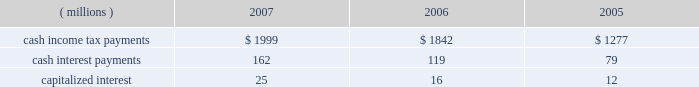In september 2006 , the fasb issued sfas no .
158 , 201cemployers 2019 accounting for defined benefit pension and other postretirement plans , an amendment of fasb statements no .
87 , 88 , 106 and 132 ( r ) . 201d this standard eliminated the requirement for a 201cminimum pension liability adjustment 201d that was previously required under sfas no .
87 and required employers to recognize the underfunded or overfunded status of a defined benefit plan as an asset or liability in its statement of financial position .
In 2006 , as a result of the implementation of sfas no .
158 , the company recognized an after-tax decrease in accumulated other comprehensive income of $ 1.187 billion and $ 513 million for the u.s .
And international pension benefit plans , respectively , and $ 218 million for the postretirement health care and life insurance benefit plan .
See note 11 for additional detail .
Reclassification adjustments are made to avoid double counting in comprehensive income items that are also recorded as part of net income .
In 2007 , as disclosed in the net periodic benefit cost table in note 11 , $ 198 million pre-tax ( $ 123 million after-tax ) were reclassified to earnings from accumulated other comprehensive income to pension and postretirement expense in the income statement .
These pension and postretirement expense amounts are shown in the table in note 11 as amortization of transition ( asset ) obligation , amortization of prior service cost ( benefit ) and amortization of net actuarial ( gain ) loss .
Other reclassification adjustments ( except for cash flow hedging instruments adjustments provided in note 12 ) were not material .
No tax provision has been made for the translation of foreign currency financial statements into u.s .
Dollars .
Note 7 .
Supplemental cash flow information .
Individual amounts in the consolidated statement of cash flows exclude the impacts of acquisitions , divestitures and exchange rate impacts , which are presented separately .
201cother 2013 net 201d in the consolidated statement of cash flows within operating activities in 2007 and 2006 includes changes in liabilities related to 3m 2019s restructuring actions ( note 4 ) and in 2005 includes the non-cash impact of adopting fin 47 ( $ 35 million cumulative effect of accounting change ) .
Transactions related to investing and financing activities with significant non-cash components are as follows : in 2007 , 3m purchased certain assets of diamond productions , inc .
For approximately 150 thousand shares of 3m common stock , which has a market value of approximately $ 13 million at the acquisition 2019s measurement date .
Liabilities assumed from acquisitions are provided in the tables in note 2. .
In 2007 what was the tax rate of the adjustment to the amount reclassified to earnings from accumulated other comprehensive income to pension and post retirement expense? 
Rationale: 61% of the adjustment to the amount reclassified to earnings from accumulated other comprehensive income to pension and post retirement expense was applied to tax
Computations: ((198 - 123) / 123)
Answer: 0.60976. 